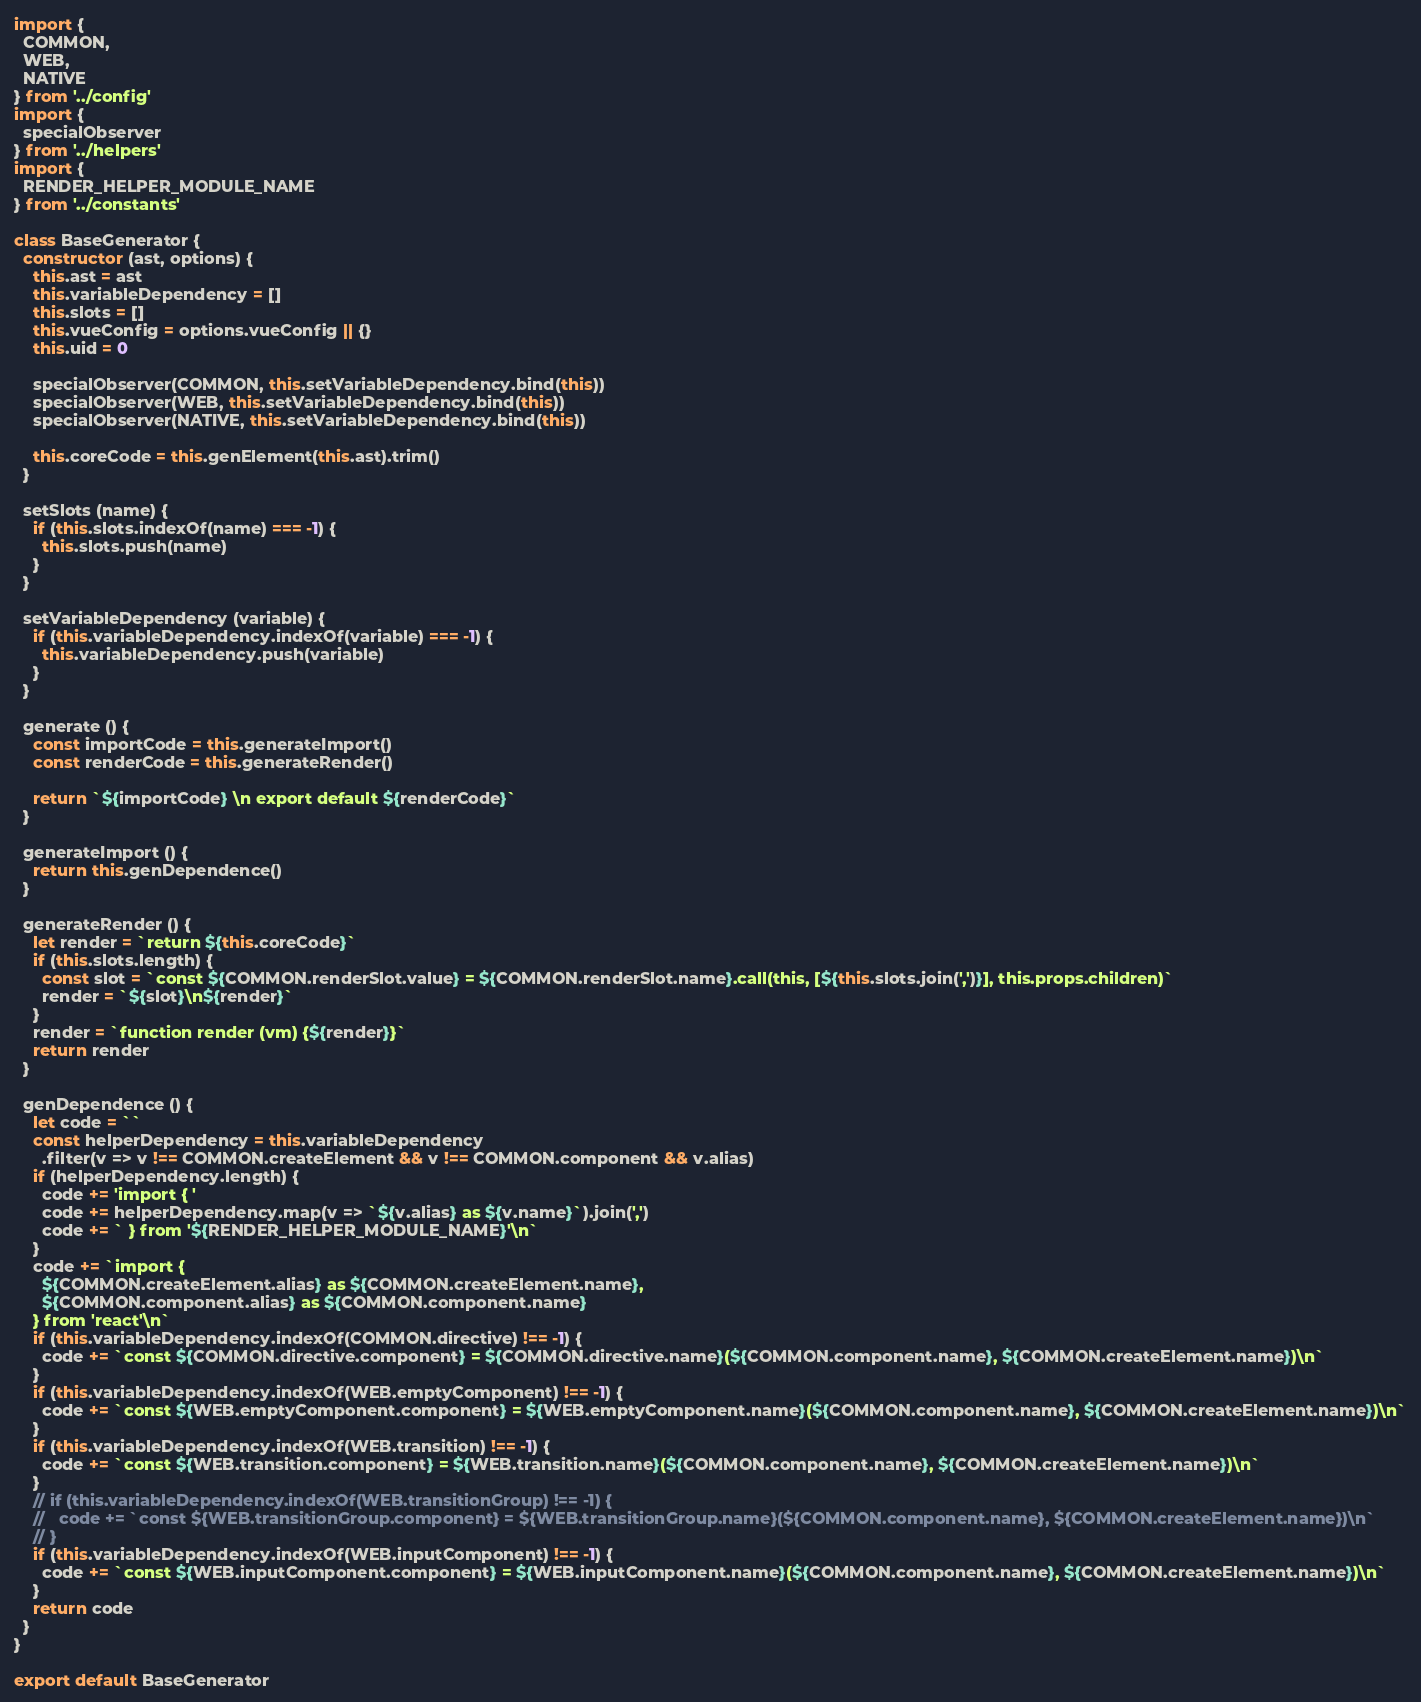Convert code to text. <code><loc_0><loc_0><loc_500><loc_500><_JavaScript_>import {
  COMMON,
  WEB,
  NATIVE
} from '../config'
import {
  specialObserver
} from '../helpers'
import {
  RENDER_HELPER_MODULE_NAME
} from '../constants'

class BaseGenerator {
  constructor (ast, options) {
    this.ast = ast
    this.variableDependency = []
    this.slots = []
    this.vueConfig = options.vueConfig || {}
    this.uid = 0

    specialObserver(COMMON, this.setVariableDependency.bind(this))
    specialObserver(WEB, this.setVariableDependency.bind(this))
    specialObserver(NATIVE, this.setVariableDependency.bind(this))

    this.coreCode = this.genElement(this.ast).trim()
  }

  setSlots (name) {
    if (this.slots.indexOf(name) === -1) {
      this.slots.push(name)
    }
  }

  setVariableDependency (variable) {
    if (this.variableDependency.indexOf(variable) === -1) {
      this.variableDependency.push(variable)
    }
  }

  generate () {
    const importCode = this.generateImport()
    const renderCode = this.generateRender()

    return `${importCode} \n export default ${renderCode}`
  }

  generateImport () {
    return this.genDependence()
  }

  generateRender () {
    let render = `return ${this.coreCode}`
    if (this.slots.length) {
      const slot = `const ${COMMON.renderSlot.value} = ${COMMON.renderSlot.name}.call(this, [${this.slots.join(',')}], this.props.children)`
      render = `${slot}\n${render}`
    }
    render = `function render (vm) {${render}}`
    return render
  }

  genDependence () {
    let code = ``
    const helperDependency = this.variableDependency
      .filter(v => v !== COMMON.createElement && v !== COMMON.component && v.alias)
    if (helperDependency.length) {
      code += 'import { '
      code += helperDependency.map(v => `${v.alias} as ${v.name}`).join(',')
      code += ` } from '${RENDER_HELPER_MODULE_NAME}'\n`
    }
    code += `import {
      ${COMMON.createElement.alias} as ${COMMON.createElement.name},
      ${COMMON.component.alias} as ${COMMON.component.name}
    } from 'react'\n`
    if (this.variableDependency.indexOf(COMMON.directive) !== -1) {
      code += `const ${COMMON.directive.component} = ${COMMON.directive.name}(${COMMON.component.name}, ${COMMON.createElement.name})\n`
    }
    if (this.variableDependency.indexOf(WEB.emptyComponent) !== -1) {
      code += `const ${WEB.emptyComponent.component} = ${WEB.emptyComponent.name}(${COMMON.component.name}, ${COMMON.createElement.name})\n`
    }
    if (this.variableDependency.indexOf(WEB.transition) !== -1) {
      code += `const ${WEB.transition.component} = ${WEB.transition.name}(${COMMON.component.name}, ${COMMON.createElement.name})\n`
    }
    // if (this.variableDependency.indexOf(WEB.transitionGroup) !== -1) {
    //   code += `const ${WEB.transitionGroup.component} = ${WEB.transitionGroup.name}(${COMMON.component.name}, ${COMMON.createElement.name})\n`
    // }
    if (this.variableDependency.indexOf(WEB.inputComponent) !== -1) {
      code += `const ${WEB.inputComponent.component} = ${WEB.inputComponent.name}(${COMMON.component.name}, ${COMMON.createElement.name})\n`
    }
    return code
  }
}

export default BaseGenerator
</code> 